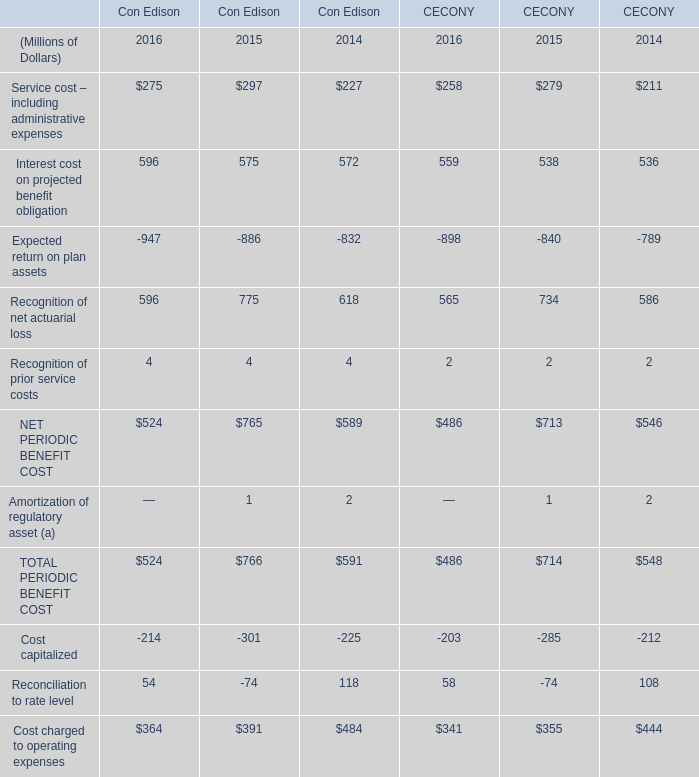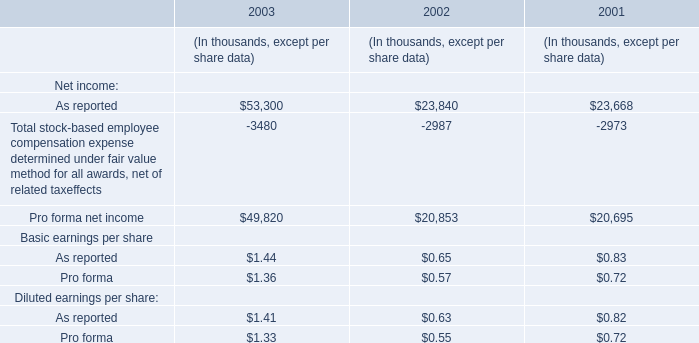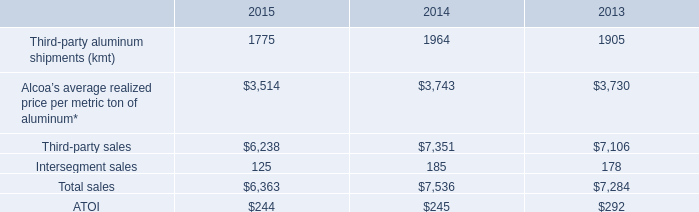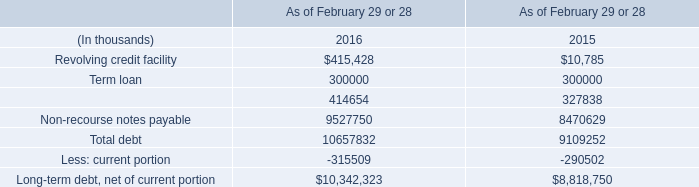If Interest cost on projected benefit obligation for Con Edison develops with the same growth rate in 2016, what will it reach in 2017? (in Million) 
Computations: (596 * (1 + ((596 - 575) / 575)))
Answer: 617.76696. 